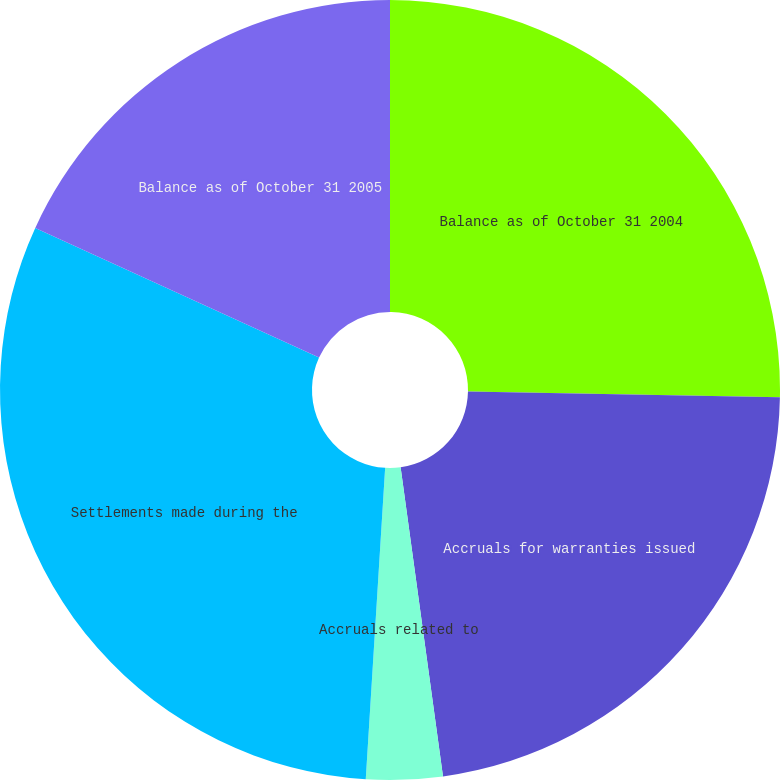<chart> <loc_0><loc_0><loc_500><loc_500><pie_chart><fcel>Balance as of October 31 2004<fcel>Accruals for warranties issued<fcel>Accruals related to<fcel>Settlements made during the<fcel>Balance as of October 31 2005<nl><fcel>25.3%<fcel>22.53%<fcel>3.16%<fcel>30.83%<fcel>18.18%<nl></chart> 